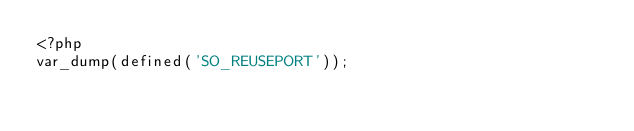<code> <loc_0><loc_0><loc_500><loc_500><_PHP_><?php
var_dump(defined('SO_REUSEPORT'));
</code> 